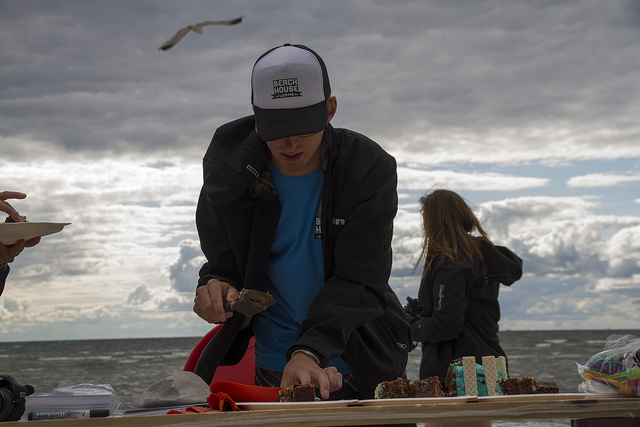Can you tell me about the setting of this image? Certainly! The image depicts an overcast day at a beach. There's a sense of casual, outdoor activity, possibly during a social event or gathering. You can also notice the somewhat dramatic clouds which could indicate that the weather was changing, or simply that it was a windy day by the sea. 